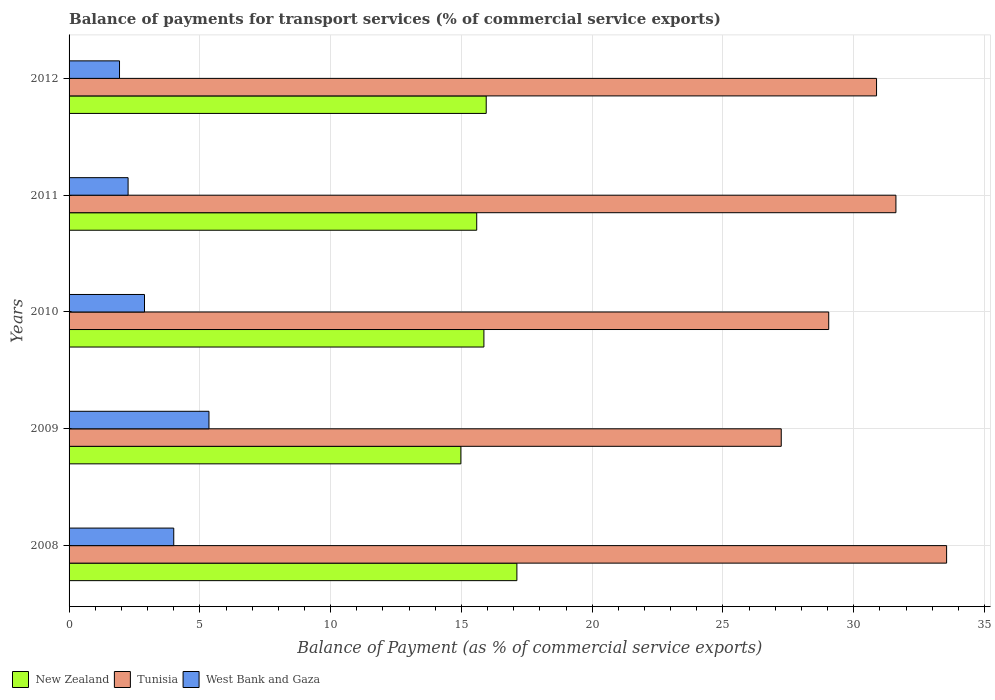Are the number of bars per tick equal to the number of legend labels?
Make the answer very short. Yes. Are the number of bars on each tick of the Y-axis equal?
Keep it short and to the point. Yes. What is the label of the 2nd group of bars from the top?
Offer a terse response. 2011. What is the balance of payments for transport services in West Bank and Gaza in 2012?
Provide a short and direct response. 1.93. Across all years, what is the maximum balance of payments for transport services in New Zealand?
Make the answer very short. 17.12. Across all years, what is the minimum balance of payments for transport services in West Bank and Gaza?
Provide a short and direct response. 1.93. In which year was the balance of payments for transport services in Tunisia maximum?
Offer a very short reply. 2008. In which year was the balance of payments for transport services in New Zealand minimum?
Provide a short and direct response. 2009. What is the total balance of payments for transport services in New Zealand in the graph?
Ensure brevity in your answer.  79.5. What is the difference between the balance of payments for transport services in Tunisia in 2010 and that in 2011?
Offer a very short reply. -2.57. What is the difference between the balance of payments for transport services in Tunisia in 2010 and the balance of payments for transport services in New Zealand in 2009?
Provide a succinct answer. 14.06. What is the average balance of payments for transport services in New Zealand per year?
Your answer should be compact. 15.9. In the year 2008, what is the difference between the balance of payments for transport services in Tunisia and balance of payments for transport services in West Bank and Gaza?
Your answer should be compact. 29.55. In how many years, is the balance of payments for transport services in New Zealand greater than 5 %?
Give a very brief answer. 5. What is the ratio of the balance of payments for transport services in Tunisia in 2008 to that in 2011?
Offer a very short reply. 1.06. What is the difference between the highest and the second highest balance of payments for transport services in West Bank and Gaza?
Your answer should be compact. 1.35. What is the difference between the highest and the lowest balance of payments for transport services in West Bank and Gaza?
Offer a terse response. 3.42. In how many years, is the balance of payments for transport services in Tunisia greater than the average balance of payments for transport services in Tunisia taken over all years?
Make the answer very short. 3. What does the 1st bar from the top in 2009 represents?
Your response must be concise. West Bank and Gaza. What does the 2nd bar from the bottom in 2011 represents?
Offer a terse response. Tunisia. Is it the case that in every year, the sum of the balance of payments for transport services in New Zealand and balance of payments for transport services in Tunisia is greater than the balance of payments for transport services in West Bank and Gaza?
Provide a succinct answer. Yes. Are all the bars in the graph horizontal?
Offer a terse response. Yes. Are the values on the major ticks of X-axis written in scientific E-notation?
Offer a terse response. No. Does the graph contain grids?
Your answer should be compact. Yes. How many legend labels are there?
Make the answer very short. 3. How are the legend labels stacked?
Ensure brevity in your answer.  Horizontal. What is the title of the graph?
Give a very brief answer. Balance of payments for transport services (% of commercial service exports). Does "Malta" appear as one of the legend labels in the graph?
Give a very brief answer. No. What is the label or title of the X-axis?
Your answer should be compact. Balance of Payment (as % of commercial service exports). What is the label or title of the Y-axis?
Offer a very short reply. Years. What is the Balance of Payment (as % of commercial service exports) in New Zealand in 2008?
Your answer should be very brief. 17.12. What is the Balance of Payment (as % of commercial service exports) of Tunisia in 2008?
Your answer should be very brief. 33.55. What is the Balance of Payment (as % of commercial service exports) of West Bank and Gaza in 2008?
Offer a very short reply. 4. What is the Balance of Payment (as % of commercial service exports) in New Zealand in 2009?
Give a very brief answer. 14.98. What is the Balance of Payment (as % of commercial service exports) in Tunisia in 2009?
Ensure brevity in your answer.  27.23. What is the Balance of Payment (as % of commercial service exports) of West Bank and Gaza in 2009?
Your response must be concise. 5.35. What is the Balance of Payment (as % of commercial service exports) in New Zealand in 2010?
Ensure brevity in your answer.  15.86. What is the Balance of Payment (as % of commercial service exports) in Tunisia in 2010?
Ensure brevity in your answer.  29.04. What is the Balance of Payment (as % of commercial service exports) in West Bank and Gaza in 2010?
Offer a very short reply. 2.88. What is the Balance of Payment (as % of commercial service exports) of New Zealand in 2011?
Ensure brevity in your answer.  15.59. What is the Balance of Payment (as % of commercial service exports) in Tunisia in 2011?
Offer a terse response. 31.61. What is the Balance of Payment (as % of commercial service exports) in West Bank and Gaza in 2011?
Keep it short and to the point. 2.26. What is the Balance of Payment (as % of commercial service exports) in New Zealand in 2012?
Offer a very short reply. 15.95. What is the Balance of Payment (as % of commercial service exports) in Tunisia in 2012?
Make the answer very short. 30.87. What is the Balance of Payment (as % of commercial service exports) in West Bank and Gaza in 2012?
Make the answer very short. 1.93. Across all years, what is the maximum Balance of Payment (as % of commercial service exports) of New Zealand?
Ensure brevity in your answer.  17.12. Across all years, what is the maximum Balance of Payment (as % of commercial service exports) of Tunisia?
Offer a very short reply. 33.55. Across all years, what is the maximum Balance of Payment (as % of commercial service exports) of West Bank and Gaza?
Offer a terse response. 5.35. Across all years, what is the minimum Balance of Payment (as % of commercial service exports) of New Zealand?
Your answer should be compact. 14.98. Across all years, what is the minimum Balance of Payment (as % of commercial service exports) of Tunisia?
Provide a succinct answer. 27.23. Across all years, what is the minimum Balance of Payment (as % of commercial service exports) of West Bank and Gaza?
Ensure brevity in your answer.  1.93. What is the total Balance of Payment (as % of commercial service exports) of New Zealand in the graph?
Provide a short and direct response. 79.5. What is the total Balance of Payment (as % of commercial service exports) of Tunisia in the graph?
Make the answer very short. 152.31. What is the total Balance of Payment (as % of commercial service exports) in West Bank and Gaza in the graph?
Give a very brief answer. 16.42. What is the difference between the Balance of Payment (as % of commercial service exports) of New Zealand in 2008 and that in 2009?
Provide a succinct answer. 2.14. What is the difference between the Balance of Payment (as % of commercial service exports) in Tunisia in 2008 and that in 2009?
Make the answer very short. 6.32. What is the difference between the Balance of Payment (as % of commercial service exports) of West Bank and Gaza in 2008 and that in 2009?
Provide a short and direct response. -1.35. What is the difference between the Balance of Payment (as % of commercial service exports) in New Zealand in 2008 and that in 2010?
Provide a short and direct response. 1.26. What is the difference between the Balance of Payment (as % of commercial service exports) of Tunisia in 2008 and that in 2010?
Offer a very short reply. 4.51. What is the difference between the Balance of Payment (as % of commercial service exports) in West Bank and Gaza in 2008 and that in 2010?
Your answer should be very brief. 1.12. What is the difference between the Balance of Payment (as % of commercial service exports) in New Zealand in 2008 and that in 2011?
Give a very brief answer. 1.54. What is the difference between the Balance of Payment (as % of commercial service exports) of Tunisia in 2008 and that in 2011?
Keep it short and to the point. 1.94. What is the difference between the Balance of Payment (as % of commercial service exports) of West Bank and Gaza in 2008 and that in 2011?
Offer a very short reply. 1.75. What is the difference between the Balance of Payment (as % of commercial service exports) of New Zealand in 2008 and that in 2012?
Keep it short and to the point. 1.17. What is the difference between the Balance of Payment (as % of commercial service exports) in Tunisia in 2008 and that in 2012?
Your answer should be compact. 2.68. What is the difference between the Balance of Payment (as % of commercial service exports) of West Bank and Gaza in 2008 and that in 2012?
Make the answer very short. 2.07. What is the difference between the Balance of Payment (as % of commercial service exports) in New Zealand in 2009 and that in 2010?
Make the answer very short. -0.88. What is the difference between the Balance of Payment (as % of commercial service exports) in Tunisia in 2009 and that in 2010?
Provide a short and direct response. -1.81. What is the difference between the Balance of Payment (as % of commercial service exports) of West Bank and Gaza in 2009 and that in 2010?
Offer a very short reply. 2.46. What is the difference between the Balance of Payment (as % of commercial service exports) of New Zealand in 2009 and that in 2011?
Provide a succinct answer. -0.61. What is the difference between the Balance of Payment (as % of commercial service exports) in Tunisia in 2009 and that in 2011?
Your response must be concise. -4.38. What is the difference between the Balance of Payment (as % of commercial service exports) in West Bank and Gaza in 2009 and that in 2011?
Your answer should be compact. 3.09. What is the difference between the Balance of Payment (as % of commercial service exports) in New Zealand in 2009 and that in 2012?
Give a very brief answer. -0.97. What is the difference between the Balance of Payment (as % of commercial service exports) in Tunisia in 2009 and that in 2012?
Provide a succinct answer. -3.64. What is the difference between the Balance of Payment (as % of commercial service exports) in West Bank and Gaza in 2009 and that in 2012?
Ensure brevity in your answer.  3.42. What is the difference between the Balance of Payment (as % of commercial service exports) in New Zealand in 2010 and that in 2011?
Offer a terse response. 0.27. What is the difference between the Balance of Payment (as % of commercial service exports) in Tunisia in 2010 and that in 2011?
Offer a very short reply. -2.57. What is the difference between the Balance of Payment (as % of commercial service exports) of West Bank and Gaza in 2010 and that in 2011?
Offer a terse response. 0.63. What is the difference between the Balance of Payment (as % of commercial service exports) in New Zealand in 2010 and that in 2012?
Make the answer very short. -0.09. What is the difference between the Balance of Payment (as % of commercial service exports) in Tunisia in 2010 and that in 2012?
Your response must be concise. -1.83. What is the difference between the Balance of Payment (as % of commercial service exports) in West Bank and Gaza in 2010 and that in 2012?
Offer a very short reply. 0.96. What is the difference between the Balance of Payment (as % of commercial service exports) of New Zealand in 2011 and that in 2012?
Provide a short and direct response. -0.36. What is the difference between the Balance of Payment (as % of commercial service exports) of Tunisia in 2011 and that in 2012?
Make the answer very short. 0.74. What is the difference between the Balance of Payment (as % of commercial service exports) of West Bank and Gaza in 2011 and that in 2012?
Ensure brevity in your answer.  0.33. What is the difference between the Balance of Payment (as % of commercial service exports) in New Zealand in 2008 and the Balance of Payment (as % of commercial service exports) in Tunisia in 2009?
Ensure brevity in your answer.  -10.11. What is the difference between the Balance of Payment (as % of commercial service exports) in New Zealand in 2008 and the Balance of Payment (as % of commercial service exports) in West Bank and Gaza in 2009?
Make the answer very short. 11.77. What is the difference between the Balance of Payment (as % of commercial service exports) of Tunisia in 2008 and the Balance of Payment (as % of commercial service exports) of West Bank and Gaza in 2009?
Ensure brevity in your answer.  28.2. What is the difference between the Balance of Payment (as % of commercial service exports) of New Zealand in 2008 and the Balance of Payment (as % of commercial service exports) of Tunisia in 2010?
Keep it short and to the point. -11.92. What is the difference between the Balance of Payment (as % of commercial service exports) of New Zealand in 2008 and the Balance of Payment (as % of commercial service exports) of West Bank and Gaza in 2010?
Provide a short and direct response. 14.24. What is the difference between the Balance of Payment (as % of commercial service exports) of Tunisia in 2008 and the Balance of Payment (as % of commercial service exports) of West Bank and Gaza in 2010?
Offer a terse response. 30.67. What is the difference between the Balance of Payment (as % of commercial service exports) in New Zealand in 2008 and the Balance of Payment (as % of commercial service exports) in Tunisia in 2011?
Offer a terse response. -14.49. What is the difference between the Balance of Payment (as % of commercial service exports) in New Zealand in 2008 and the Balance of Payment (as % of commercial service exports) in West Bank and Gaza in 2011?
Your response must be concise. 14.86. What is the difference between the Balance of Payment (as % of commercial service exports) in Tunisia in 2008 and the Balance of Payment (as % of commercial service exports) in West Bank and Gaza in 2011?
Give a very brief answer. 31.29. What is the difference between the Balance of Payment (as % of commercial service exports) in New Zealand in 2008 and the Balance of Payment (as % of commercial service exports) in Tunisia in 2012?
Provide a succinct answer. -13.75. What is the difference between the Balance of Payment (as % of commercial service exports) in New Zealand in 2008 and the Balance of Payment (as % of commercial service exports) in West Bank and Gaza in 2012?
Ensure brevity in your answer.  15.19. What is the difference between the Balance of Payment (as % of commercial service exports) in Tunisia in 2008 and the Balance of Payment (as % of commercial service exports) in West Bank and Gaza in 2012?
Ensure brevity in your answer.  31.62. What is the difference between the Balance of Payment (as % of commercial service exports) of New Zealand in 2009 and the Balance of Payment (as % of commercial service exports) of Tunisia in 2010?
Keep it short and to the point. -14.06. What is the difference between the Balance of Payment (as % of commercial service exports) of New Zealand in 2009 and the Balance of Payment (as % of commercial service exports) of West Bank and Gaza in 2010?
Offer a terse response. 12.1. What is the difference between the Balance of Payment (as % of commercial service exports) in Tunisia in 2009 and the Balance of Payment (as % of commercial service exports) in West Bank and Gaza in 2010?
Offer a terse response. 24.34. What is the difference between the Balance of Payment (as % of commercial service exports) of New Zealand in 2009 and the Balance of Payment (as % of commercial service exports) of Tunisia in 2011?
Your answer should be compact. -16.63. What is the difference between the Balance of Payment (as % of commercial service exports) of New Zealand in 2009 and the Balance of Payment (as % of commercial service exports) of West Bank and Gaza in 2011?
Give a very brief answer. 12.72. What is the difference between the Balance of Payment (as % of commercial service exports) in Tunisia in 2009 and the Balance of Payment (as % of commercial service exports) in West Bank and Gaza in 2011?
Provide a short and direct response. 24.97. What is the difference between the Balance of Payment (as % of commercial service exports) of New Zealand in 2009 and the Balance of Payment (as % of commercial service exports) of Tunisia in 2012?
Your response must be concise. -15.89. What is the difference between the Balance of Payment (as % of commercial service exports) in New Zealand in 2009 and the Balance of Payment (as % of commercial service exports) in West Bank and Gaza in 2012?
Keep it short and to the point. 13.05. What is the difference between the Balance of Payment (as % of commercial service exports) in Tunisia in 2009 and the Balance of Payment (as % of commercial service exports) in West Bank and Gaza in 2012?
Offer a very short reply. 25.3. What is the difference between the Balance of Payment (as % of commercial service exports) in New Zealand in 2010 and the Balance of Payment (as % of commercial service exports) in Tunisia in 2011?
Provide a short and direct response. -15.75. What is the difference between the Balance of Payment (as % of commercial service exports) of New Zealand in 2010 and the Balance of Payment (as % of commercial service exports) of West Bank and Gaza in 2011?
Offer a terse response. 13.6. What is the difference between the Balance of Payment (as % of commercial service exports) in Tunisia in 2010 and the Balance of Payment (as % of commercial service exports) in West Bank and Gaza in 2011?
Offer a terse response. 26.79. What is the difference between the Balance of Payment (as % of commercial service exports) of New Zealand in 2010 and the Balance of Payment (as % of commercial service exports) of Tunisia in 2012?
Offer a terse response. -15.01. What is the difference between the Balance of Payment (as % of commercial service exports) in New Zealand in 2010 and the Balance of Payment (as % of commercial service exports) in West Bank and Gaza in 2012?
Your answer should be compact. 13.93. What is the difference between the Balance of Payment (as % of commercial service exports) in Tunisia in 2010 and the Balance of Payment (as % of commercial service exports) in West Bank and Gaza in 2012?
Give a very brief answer. 27.12. What is the difference between the Balance of Payment (as % of commercial service exports) of New Zealand in 2011 and the Balance of Payment (as % of commercial service exports) of Tunisia in 2012?
Ensure brevity in your answer.  -15.29. What is the difference between the Balance of Payment (as % of commercial service exports) of New Zealand in 2011 and the Balance of Payment (as % of commercial service exports) of West Bank and Gaza in 2012?
Your answer should be compact. 13.66. What is the difference between the Balance of Payment (as % of commercial service exports) in Tunisia in 2011 and the Balance of Payment (as % of commercial service exports) in West Bank and Gaza in 2012?
Offer a very short reply. 29.69. What is the average Balance of Payment (as % of commercial service exports) in New Zealand per year?
Offer a very short reply. 15.9. What is the average Balance of Payment (as % of commercial service exports) in Tunisia per year?
Your answer should be compact. 30.46. What is the average Balance of Payment (as % of commercial service exports) of West Bank and Gaza per year?
Make the answer very short. 3.28. In the year 2008, what is the difference between the Balance of Payment (as % of commercial service exports) of New Zealand and Balance of Payment (as % of commercial service exports) of Tunisia?
Give a very brief answer. -16.43. In the year 2008, what is the difference between the Balance of Payment (as % of commercial service exports) of New Zealand and Balance of Payment (as % of commercial service exports) of West Bank and Gaza?
Provide a short and direct response. 13.12. In the year 2008, what is the difference between the Balance of Payment (as % of commercial service exports) of Tunisia and Balance of Payment (as % of commercial service exports) of West Bank and Gaza?
Provide a succinct answer. 29.55. In the year 2009, what is the difference between the Balance of Payment (as % of commercial service exports) in New Zealand and Balance of Payment (as % of commercial service exports) in Tunisia?
Offer a terse response. -12.25. In the year 2009, what is the difference between the Balance of Payment (as % of commercial service exports) in New Zealand and Balance of Payment (as % of commercial service exports) in West Bank and Gaza?
Keep it short and to the point. 9.63. In the year 2009, what is the difference between the Balance of Payment (as % of commercial service exports) in Tunisia and Balance of Payment (as % of commercial service exports) in West Bank and Gaza?
Keep it short and to the point. 21.88. In the year 2010, what is the difference between the Balance of Payment (as % of commercial service exports) of New Zealand and Balance of Payment (as % of commercial service exports) of Tunisia?
Offer a terse response. -13.18. In the year 2010, what is the difference between the Balance of Payment (as % of commercial service exports) of New Zealand and Balance of Payment (as % of commercial service exports) of West Bank and Gaza?
Your answer should be compact. 12.98. In the year 2010, what is the difference between the Balance of Payment (as % of commercial service exports) in Tunisia and Balance of Payment (as % of commercial service exports) in West Bank and Gaza?
Offer a terse response. 26.16. In the year 2011, what is the difference between the Balance of Payment (as % of commercial service exports) in New Zealand and Balance of Payment (as % of commercial service exports) in Tunisia?
Provide a succinct answer. -16.03. In the year 2011, what is the difference between the Balance of Payment (as % of commercial service exports) of New Zealand and Balance of Payment (as % of commercial service exports) of West Bank and Gaza?
Your answer should be very brief. 13.33. In the year 2011, what is the difference between the Balance of Payment (as % of commercial service exports) in Tunisia and Balance of Payment (as % of commercial service exports) in West Bank and Gaza?
Offer a terse response. 29.36. In the year 2012, what is the difference between the Balance of Payment (as % of commercial service exports) in New Zealand and Balance of Payment (as % of commercial service exports) in Tunisia?
Your response must be concise. -14.92. In the year 2012, what is the difference between the Balance of Payment (as % of commercial service exports) in New Zealand and Balance of Payment (as % of commercial service exports) in West Bank and Gaza?
Keep it short and to the point. 14.02. In the year 2012, what is the difference between the Balance of Payment (as % of commercial service exports) in Tunisia and Balance of Payment (as % of commercial service exports) in West Bank and Gaza?
Your answer should be compact. 28.94. What is the ratio of the Balance of Payment (as % of commercial service exports) in New Zealand in 2008 to that in 2009?
Your response must be concise. 1.14. What is the ratio of the Balance of Payment (as % of commercial service exports) in Tunisia in 2008 to that in 2009?
Your answer should be very brief. 1.23. What is the ratio of the Balance of Payment (as % of commercial service exports) of West Bank and Gaza in 2008 to that in 2009?
Keep it short and to the point. 0.75. What is the ratio of the Balance of Payment (as % of commercial service exports) of New Zealand in 2008 to that in 2010?
Make the answer very short. 1.08. What is the ratio of the Balance of Payment (as % of commercial service exports) in Tunisia in 2008 to that in 2010?
Offer a very short reply. 1.16. What is the ratio of the Balance of Payment (as % of commercial service exports) in West Bank and Gaza in 2008 to that in 2010?
Your response must be concise. 1.39. What is the ratio of the Balance of Payment (as % of commercial service exports) in New Zealand in 2008 to that in 2011?
Provide a succinct answer. 1.1. What is the ratio of the Balance of Payment (as % of commercial service exports) of Tunisia in 2008 to that in 2011?
Make the answer very short. 1.06. What is the ratio of the Balance of Payment (as % of commercial service exports) in West Bank and Gaza in 2008 to that in 2011?
Your response must be concise. 1.77. What is the ratio of the Balance of Payment (as % of commercial service exports) of New Zealand in 2008 to that in 2012?
Offer a very short reply. 1.07. What is the ratio of the Balance of Payment (as % of commercial service exports) in Tunisia in 2008 to that in 2012?
Ensure brevity in your answer.  1.09. What is the ratio of the Balance of Payment (as % of commercial service exports) in West Bank and Gaza in 2008 to that in 2012?
Give a very brief answer. 2.08. What is the ratio of the Balance of Payment (as % of commercial service exports) in New Zealand in 2009 to that in 2010?
Your answer should be compact. 0.94. What is the ratio of the Balance of Payment (as % of commercial service exports) of Tunisia in 2009 to that in 2010?
Offer a terse response. 0.94. What is the ratio of the Balance of Payment (as % of commercial service exports) in West Bank and Gaza in 2009 to that in 2010?
Your response must be concise. 1.85. What is the ratio of the Balance of Payment (as % of commercial service exports) in New Zealand in 2009 to that in 2011?
Offer a very short reply. 0.96. What is the ratio of the Balance of Payment (as % of commercial service exports) in Tunisia in 2009 to that in 2011?
Provide a succinct answer. 0.86. What is the ratio of the Balance of Payment (as % of commercial service exports) in West Bank and Gaza in 2009 to that in 2011?
Make the answer very short. 2.37. What is the ratio of the Balance of Payment (as % of commercial service exports) of New Zealand in 2009 to that in 2012?
Your answer should be compact. 0.94. What is the ratio of the Balance of Payment (as % of commercial service exports) of Tunisia in 2009 to that in 2012?
Offer a very short reply. 0.88. What is the ratio of the Balance of Payment (as % of commercial service exports) of West Bank and Gaza in 2009 to that in 2012?
Your response must be concise. 2.77. What is the ratio of the Balance of Payment (as % of commercial service exports) in New Zealand in 2010 to that in 2011?
Provide a succinct answer. 1.02. What is the ratio of the Balance of Payment (as % of commercial service exports) in Tunisia in 2010 to that in 2011?
Offer a very short reply. 0.92. What is the ratio of the Balance of Payment (as % of commercial service exports) in West Bank and Gaza in 2010 to that in 2011?
Your answer should be very brief. 1.28. What is the ratio of the Balance of Payment (as % of commercial service exports) of Tunisia in 2010 to that in 2012?
Keep it short and to the point. 0.94. What is the ratio of the Balance of Payment (as % of commercial service exports) of West Bank and Gaza in 2010 to that in 2012?
Your answer should be very brief. 1.5. What is the ratio of the Balance of Payment (as % of commercial service exports) of New Zealand in 2011 to that in 2012?
Offer a terse response. 0.98. What is the ratio of the Balance of Payment (as % of commercial service exports) in West Bank and Gaza in 2011 to that in 2012?
Provide a short and direct response. 1.17. What is the difference between the highest and the second highest Balance of Payment (as % of commercial service exports) in New Zealand?
Your answer should be compact. 1.17. What is the difference between the highest and the second highest Balance of Payment (as % of commercial service exports) in Tunisia?
Ensure brevity in your answer.  1.94. What is the difference between the highest and the second highest Balance of Payment (as % of commercial service exports) of West Bank and Gaza?
Offer a very short reply. 1.35. What is the difference between the highest and the lowest Balance of Payment (as % of commercial service exports) of New Zealand?
Your answer should be very brief. 2.14. What is the difference between the highest and the lowest Balance of Payment (as % of commercial service exports) of Tunisia?
Your answer should be compact. 6.32. What is the difference between the highest and the lowest Balance of Payment (as % of commercial service exports) in West Bank and Gaza?
Your answer should be compact. 3.42. 